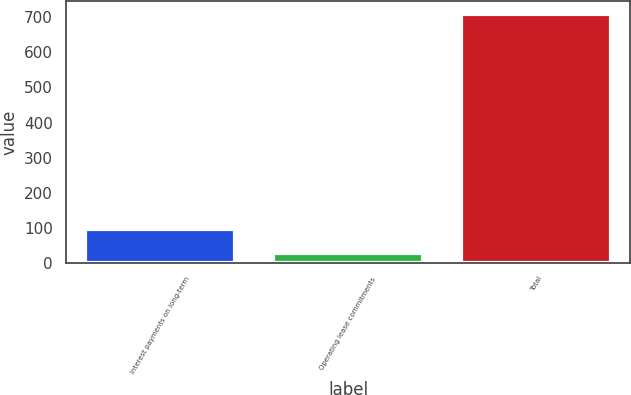<chart> <loc_0><loc_0><loc_500><loc_500><bar_chart><fcel>Interest payments on long-term<fcel>Operating lease commitments<fcel>Total<nl><fcel>96.3<fcel>28<fcel>711<nl></chart> 